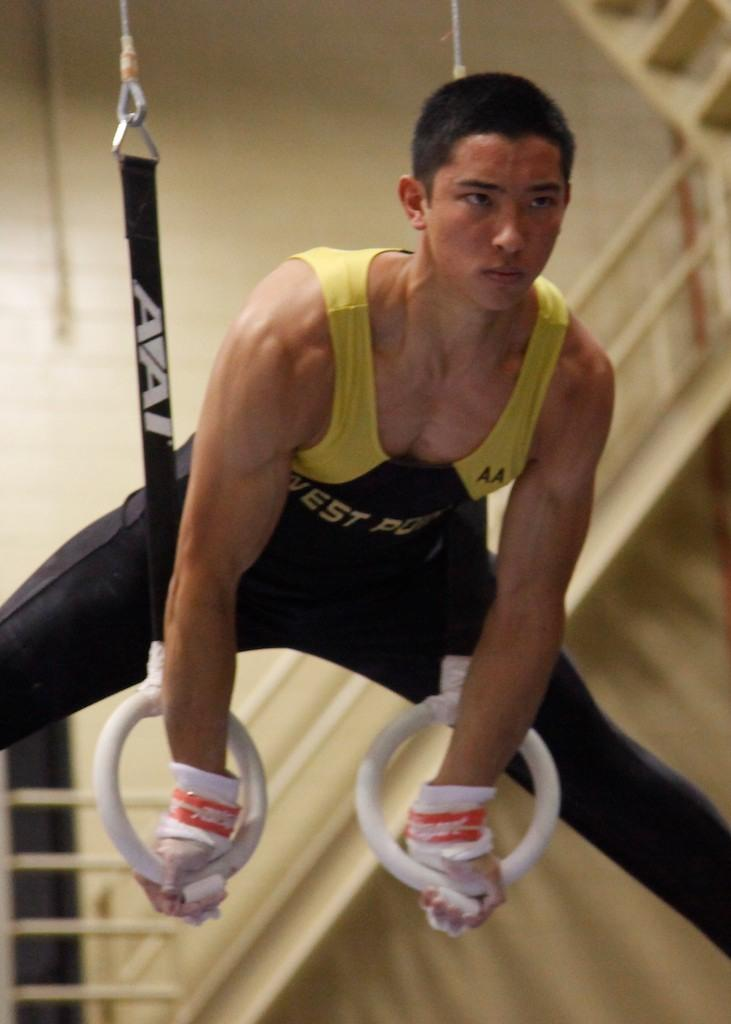What is the man in the image doing? The man is performing gymnastics with rings. Can you describe the background of the image? There is a railing in the background. What type of jewel is the man wearing on his finger while performing gymnastics? There is no jewel visible on the man's finger in the image. How does the faucet affect the man's gymnastics performance in the image? There is no faucet present in the image, so it does not affect the man's performance. 